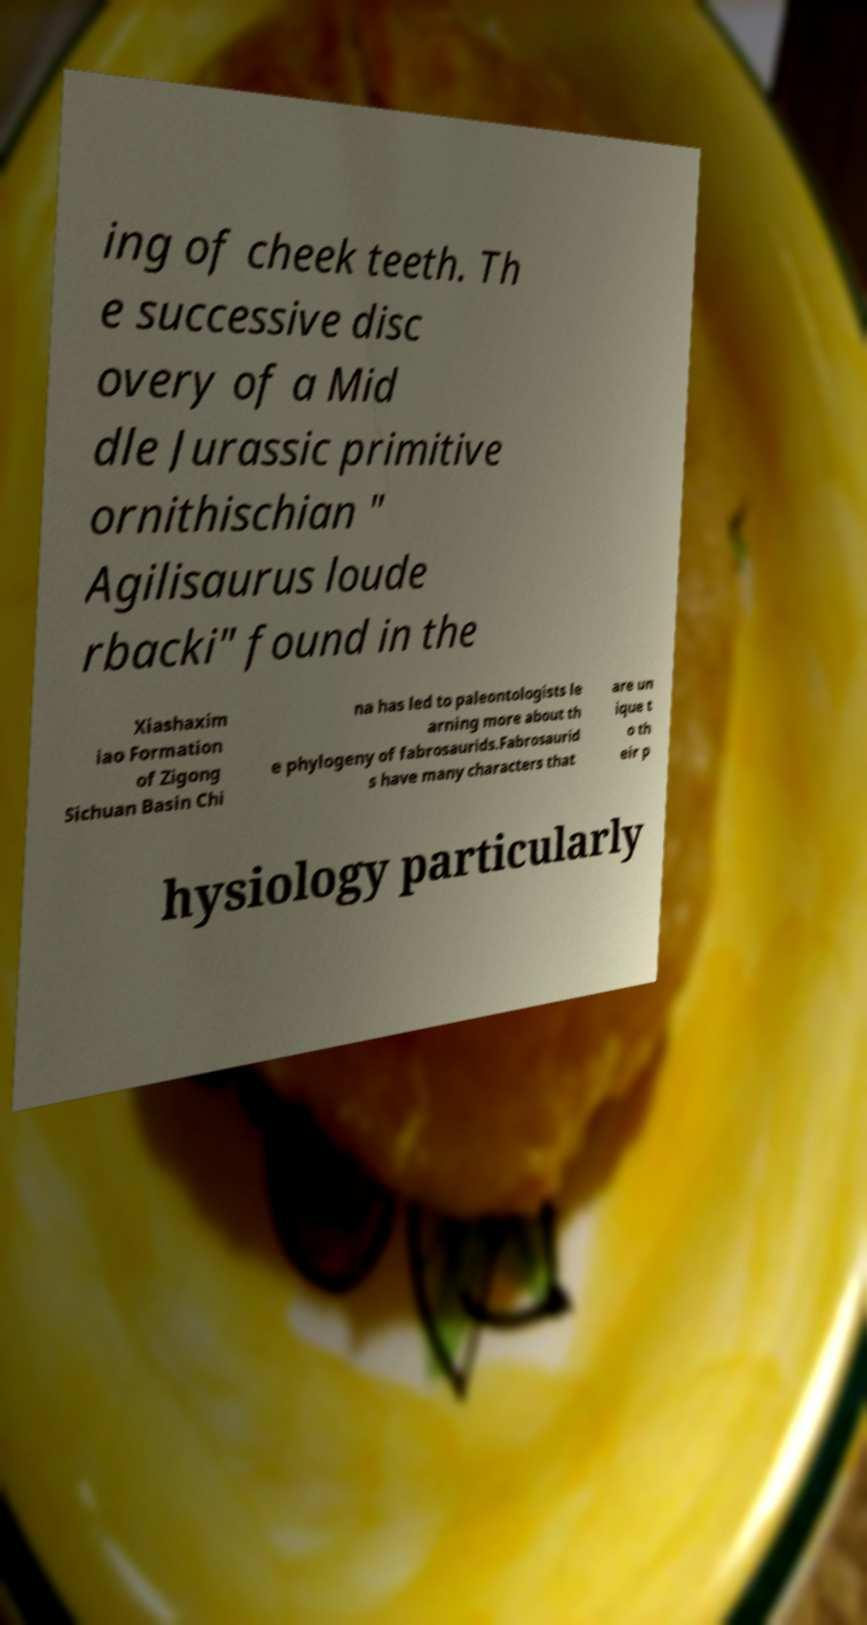Please read and relay the text visible in this image. What does it say? ing of cheek teeth. Th e successive disc overy of a Mid dle Jurassic primitive ornithischian " Agilisaurus loude rbacki" found in the Xiashaxim iao Formation of Zigong Sichuan Basin Chi na has led to paleontologists le arning more about th e phylogeny of fabrosaurids.Fabrosaurid s have many characters that are un ique t o th eir p hysiology particularly 